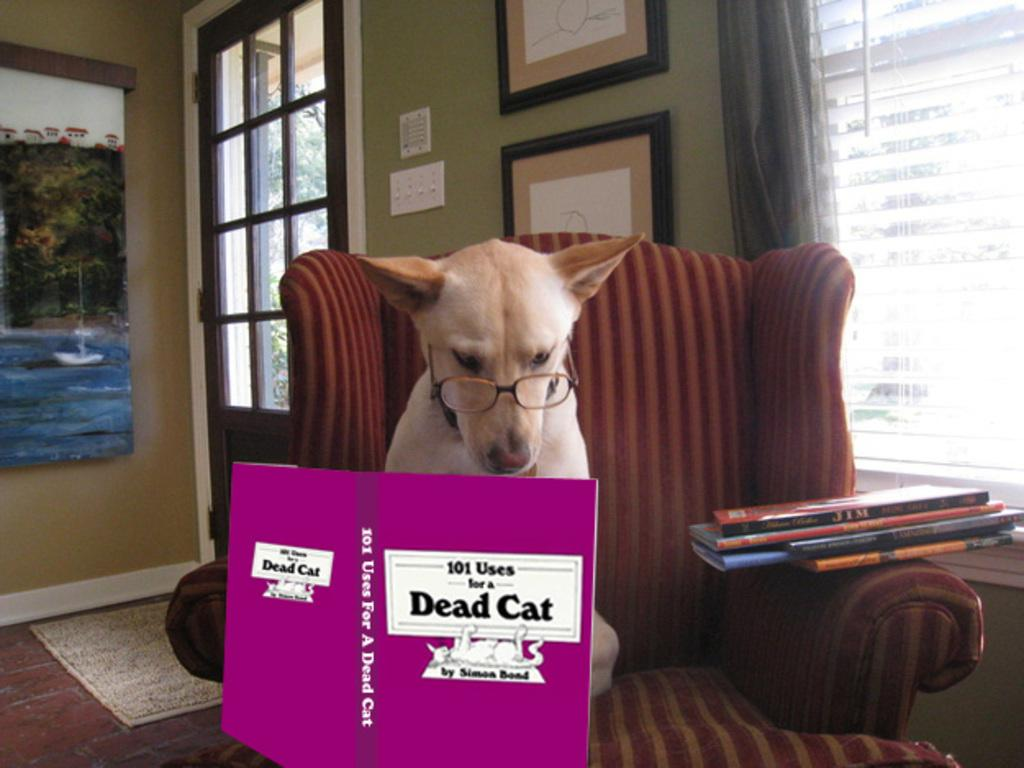What type of structure can be seen in the image? There is a wall in the image. What is hanging on the wall? There is a photo frame in the image. Is there any entrance or exit visible in the image? Yes, there is a door in the image. What is the dog doing in the image? The dog is sitting on a sofa in the image. What can be seen on the shelves or surfaces in the image? There are books in the image. What type of yam is being cooked in the field in the image? There is no yam or field present in the image; it features a wall, a photo frame, a door, a dog sitting on a sofa, and books. 